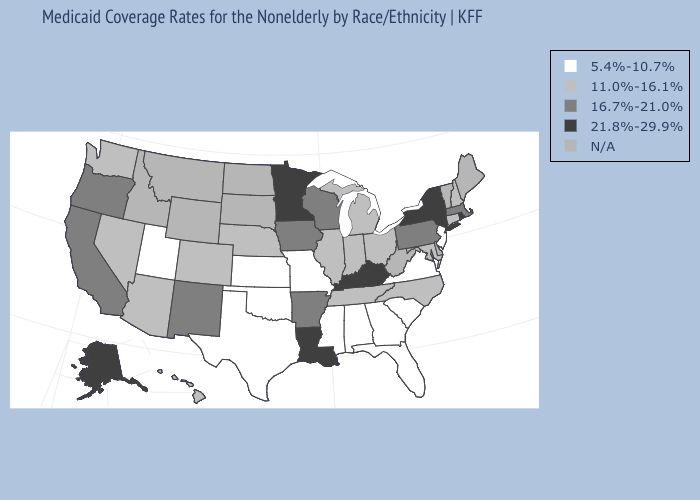What is the value of South Carolina?
Concise answer only. 5.4%-10.7%. Name the states that have a value in the range 11.0%-16.1%?
Concise answer only. Arizona, Colorado, Connecticut, Hawaii, Illinois, Indiana, Maryland, Michigan, Nebraska, Nevada, New Hampshire, North Carolina, Ohio, Tennessee, Washington. Name the states that have a value in the range N/A?
Quick response, please. Delaware, Idaho, Maine, Montana, North Dakota, South Dakota, Vermont, West Virginia, Wyoming. What is the lowest value in the Northeast?
Short answer required. 5.4%-10.7%. What is the lowest value in the USA?
Write a very short answer. 5.4%-10.7%. Name the states that have a value in the range 11.0%-16.1%?
Quick response, please. Arizona, Colorado, Connecticut, Hawaii, Illinois, Indiana, Maryland, Michigan, Nebraska, Nevada, New Hampshire, North Carolina, Ohio, Tennessee, Washington. Name the states that have a value in the range 5.4%-10.7%?
Give a very brief answer. Alabama, Florida, Georgia, Kansas, Mississippi, Missouri, New Jersey, Oklahoma, South Carolina, Texas, Utah, Virginia. Name the states that have a value in the range 21.8%-29.9%?
Concise answer only. Alaska, Kentucky, Louisiana, Minnesota, New York, Rhode Island. What is the lowest value in the USA?
Short answer required. 5.4%-10.7%. Which states have the lowest value in the USA?
Quick response, please. Alabama, Florida, Georgia, Kansas, Mississippi, Missouri, New Jersey, Oklahoma, South Carolina, Texas, Utah, Virginia. What is the lowest value in the MidWest?
Short answer required. 5.4%-10.7%. What is the value of Pennsylvania?
Concise answer only. 16.7%-21.0%. Among the states that border Maine , which have the lowest value?
Short answer required. New Hampshire. Does Missouri have the lowest value in the MidWest?
Short answer required. Yes. 